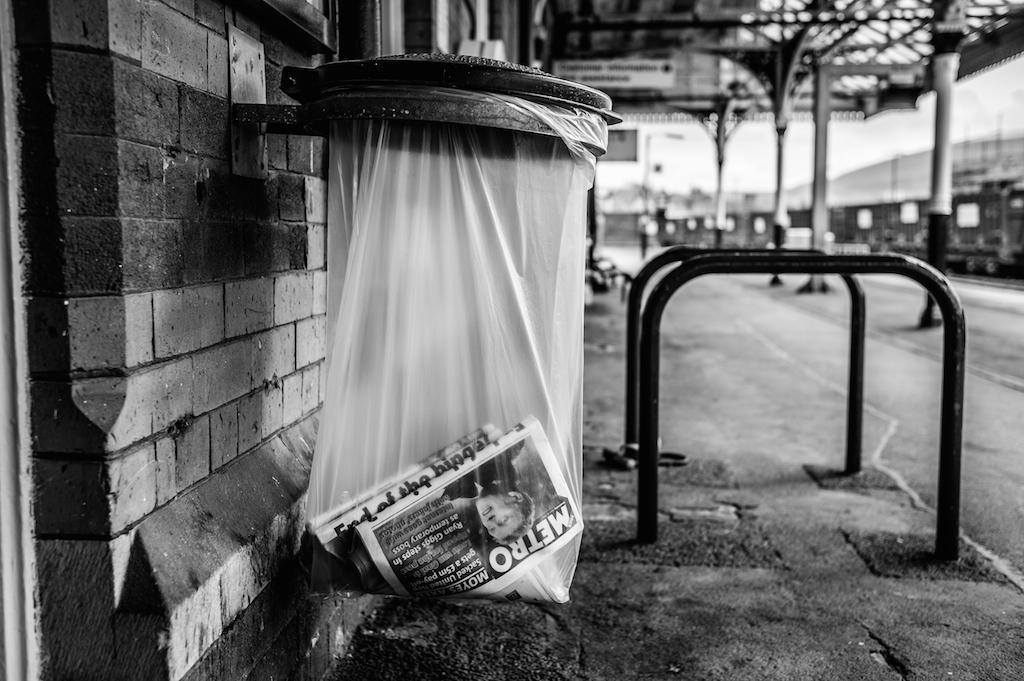<image>
Render a clear and concise summary of the photo. A plastic bag hanging on the side of a street contains a Metro newspaper. 